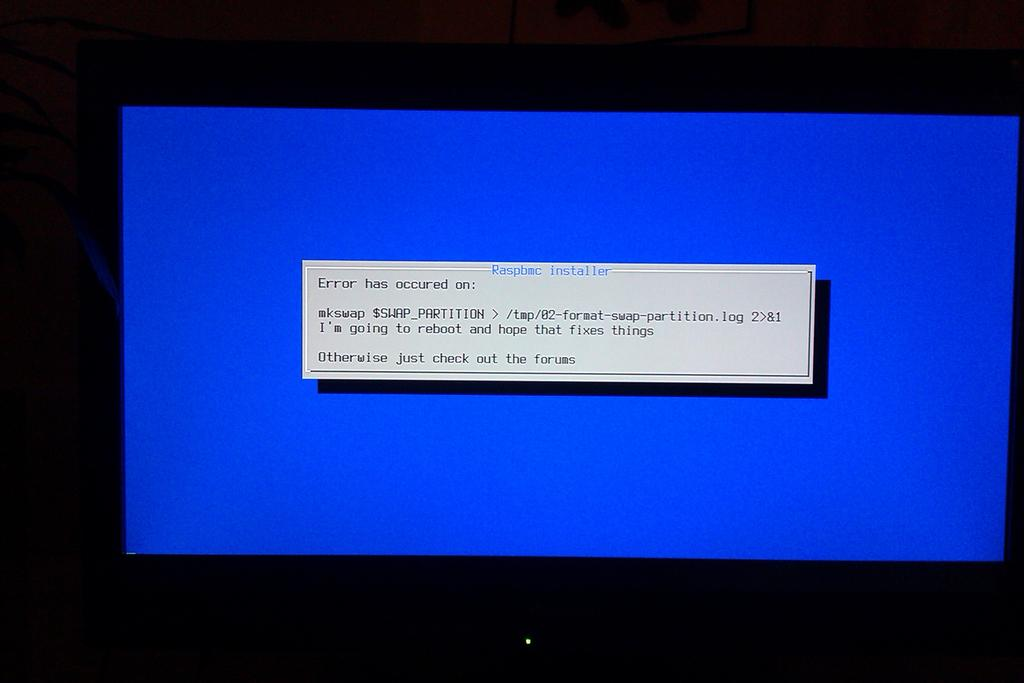<image>
Summarize the visual content of the image. Blue screen with an error saying to check the forums. 